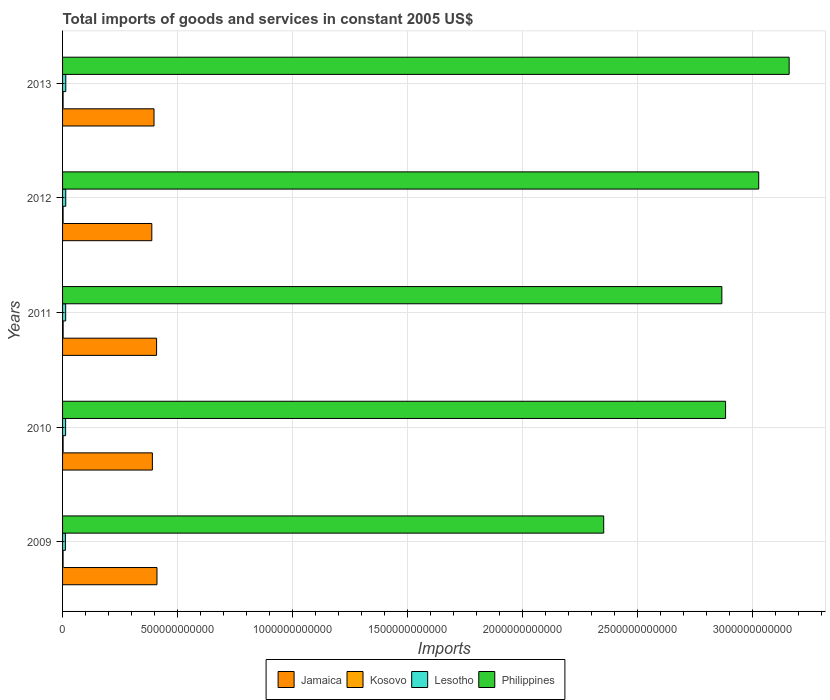How many bars are there on the 3rd tick from the bottom?
Make the answer very short. 4. In how many cases, is the number of bars for a given year not equal to the number of legend labels?
Ensure brevity in your answer.  0. What is the total imports of goods and services in Kosovo in 2012?
Your answer should be very brief. 2.33e+09. Across all years, what is the maximum total imports of goods and services in Lesotho?
Make the answer very short. 1.41e+1. Across all years, what is the minimum total imports of goods and services in Jamaica?
Provide a short and direct response. 3.88e+11. In which year was the total imports of goods and services in Lesotho maximum?
Your answer should be very brief. 2013. In which year was the total imports of goods and services in Jamaica minimum?
Give a very brief answer. 2012. What is the total total imports of goods and services in Jamaica in the graph?
Make the answer very short. 2.00e+12. What is the difference between the total imports of goods and services in Kosovo in 2012 and that in 2013?
Offer a terse response. 3.50e+07. What is the difference between the total imports of goods and services in Kosovo in 2009 and the total imports of goods and services in Jamaica in 2012?
Give a very brief answer. -3.86e+11. What is the average total imports of goods and services in Philippines per year?
Ensure brevity in your answer.  2.86e+12. In the year 2009, what is the difference between the total imports of goods and services in Jamaica and total imports of goods and services in Lesotho?
Ensure brevity in your answer.  3.98e+11. In how many years, is the total imports of goods and services in Lesotho greater than 3200000000000 US$?
Ensure brevity in your answer.  0. What is the ratio of the total imports of goods and services in Jamaica in 2010 to that in 2012?
Keep it short and to the point. 1.01. Is the total imports of goods and services in Kosovo in 2009 less than that in 2012?
Make the answer very short. Yes. Is the difference between the total imports of goods and services in Jamaica in 2011 and 2013 greater than the difference between the total imports of goods and services in Lesotho in 2011 and 2013?
Offer a terse response. Yes. What is the difference between the highest and the second highest total imports of goods and services in Kosovo?
Provide a succinct answer. 9.00e+07. What is the difference between the highest and the lowest total imports of goods and services in Kosovo?
Your answer should be very brief. 2.95e+08. In how many years, is the total imports of goods and services in Kosovo greater than the average total imports of goods and services in Kosovo taken over all years?
Offer a terse response. 2. Is it the case that in every year, the sum of the total imports of goods and services in Kosovo and total imports of goods and services in Lesotho is greater than the sum of total imports of goods and services in Philippines and total imports of goods and services in Jamaica?
Provide a succinct answer. No. What does the 2nd bar from the top in 2013 represents?
Provide a succinct answer. Lesotho. What does the 1st bar from the bottom in 2009 represents?
Offer a terse response. Jamaica. Are all the bars in the graph horizontal?
Your answer should be very brief. Yes. What is the difference between two consecutive major ticks on the X-axis?
Your answer should be compact. 5.00e+11. Are the values on the major ticks of X-axis written in scientific E-notation?
Ensure brevity in your answer.  No. Does the graph contain grids?
Provide a succinct answer. Yes. Where does the legend appear in the graph?
Your response must be concise. Bottom center. What is the title of the graph?
Your answer should be very brief. Total imports of goods and services in constant 2005 US$. What is the label or title of the X-axis?
Keep it short and to the point. Imports. What is the label or title of the Y-axis?
Your answer should be compact. Years. What is the Imports in Jamaica in 2009?
Give a very brief answer. 4.11e+11. What is the Imports of Kosovo in 2009?
Your answer should be compact. 2.23e+09. What is the Imports in Lesotho in 2009?
Provide a succinct answer. 1.23e+1. What is the Imports of Philippines in 2009?
Your answer should be compact. 2.35e+12. What is the Imports in Jamaica in 2010?
Provide a short and direct response. 3.91e+11. What is the Imports of Kosovo in 2010?
Make the answer very short. 2.44e+09. What is the Imports of Lesotho in 2010?
Ensure brevity in your answer.  1.32e+1. What is the Imports in Philippines in 2010?
Ensure brevity in your answer.  2.88e+12. What is the Imports of Jamaica in 2011?
Give a very brief answer. 4.09e+11. What is the Imports of Kosovo in 2011?
Keep it short and to the point. 2.53e+09. What is the Imports of Lesotho in 2011?
Your answer should be compact. 1.35e+1. What is the Imports in Philippines in 2011?
Ensure brevity in your answer.  2.87e+12. What is the Imports in Jamaica in 2012?
Provide a succinct answer. 3.88e+11. What is the Imports of Kosovo in 2012?
Offer a very short reply. 2.33e+09. What is the Imports of Lesotho in 2012?
Your answer should be compact. 1.39e+1. What is the Imports in Philippines in 2012?
Keep it short and to the point. 3.03e+12. What is the Imports of Jamaica in 2013?
Provide a short and direct response. 3.98e+11. What is the Imports in Kosovo in 2013?
Provide a succinct answer. 2.30e+09. What is the Imports in Lesotho in 2013?
Your answer should be very brief. 1.41e+1. What is the Imports in Philippines in 2013?
Offer a very short reply. 3.16e+12. Across all years, what is the maximum Imports of Jamaica?
Ensure brevity in your answer.  4.11e+11. Across all years, what is the maximum Imports in Kosovo?
Give a very brief answer. 2.53e+09. Across all years, what is the maximum Imports of Lesotho?
Offer a very short reply. 1.41e+1. Across all years, what is the maximum Imports of Philippines?
Your answer should be very brief. 3.16e+12. Across all years, what is the minimum Imports in Jamaica?
Provide a short and direct response. 3.88e+11. Across all years, what is the minimum Imports of Kosovo?
Keep it short and to the point. 2.23e+09. Across all years, what is the minimum Imports in Lesotho?
Your response must be concise. 1.23e+1. Across all years, what is the minimum Imports in Philippines?
Make the answer very short. 2.35e+12. What is the total Imports of Jamaica in the graph?
Provide a short and direct response. 2.00e+12. What is the total Imports in Kosovo in the graph?
Keep it short and to the point. 1.18e+1. What is the total Imports of Lesotho in the graph?
Give a very brief answer. 6.69e+1. What is the total Imports in Philippines in the graph?
Offer a very short reply. 1.43e+13. What is the difference between the Imports of Jamaica in 2009 and that in 2010?
Keep it short and to the point. 2.01e+1. What is the difference between the Imports in Kosovo in 2009 and that in 2010?
Provide a short and direct response. -2.05e+08. What is the difference between the Imports in Lesotho in 2009 and that in 2010?
Offer a very short reply. -9.55e+08. What is the difference between the Imports in Philippines in 2009 and that in 2010?
Make the answer very short. -5.30e+11. What is the difference between the Imports of Jamaica in 2009 and that in 2011?
Offer a terse response. 1.80e+09. What is the difference between the Imports in Kosovo in 2009 and that in 2011?
Offer a very short reply. -2.95e+08. What is the difference between the Imports of Lesotho in 2009 and that in 2011?
Make the answer very short. -1.24e+09. What is the difference between the Imports in Philippines in 2009 and that in 2011?
Ensure brevity in your answer.  -5.14e+11. What is the difference between the Imports in Jamaica in 2009 and that in 2012?
Offer a terse response. 2.25e+1. What is the difference between the Imports of Kosovo in 2009 and that in 2012?
Your response must be concise. -1.03e+08. What is the difference between the Imports in Lesotho in 2009 and that in 2012?
Offer a terse response. -1.59e+09. What is the difference between the Imports of Philippines in 2009 and that in 2012?
Ensure brevity in your answer.  -6.74e+11. What is the difference between the Imports in Jamaica in 2009 and that in 2013?
Make the answer very short. 1.29e+1. What is the difference between the Imports in Kosovo in 2009 and that in 2013?
Your answer should be compact. -6.79e+07. What is the difference between the Imports in Lesotho in 2009 and that in 2013?
Provide a succinct answer. -1.78e+09. What is the difference between the Imports of Philippines in 2009 and that in 2013?
Give a very brief answer. -8.07e+11. What is the difference between the Imports in Jamaica in 2010 and that in 2011?
Your answer should be compact. -1.83e+1. What is the difference between the Imports in Kosovo in 2010 and that in 2011?
Provide a succinct answer. -9.00e+07. What is the difference between the Imports in Lesotho in 2010 and that in 2011?
Keep it short and to the point. -2.89e+08. What is the difference between the Imports of Philippines in 2010 and that in 2011?
Your answer should be compact. 1.61e+1. What is the difference between the Imports of Jamaica in 2010 and that in 2012?
Your answer should be compact. 2.44e+09. What is the difference between the Imports in Kosovo in 2010 and that in 2012?
Keep it short and to the point. 1.02e+08. What is the difference between the Imports of Lesotho in 2010 and that in 2012?
Ensure brevity in your answer.  -6.33e+08. What is the difference between the Imports in Philippines in 2010 and that in 2012?
Provide a succinct answer. -1.44e+11. What is the difference between the Imports of Jamaica in 2010 and that in 2013?
Make the answer very short. -7.20e+09. What is the difference between the Imports in Kosovo in 2010 and that in 2013?
Ensure brevity in your answer.  1.37e+08. What is the difference between the Imports in Lesotho in 2010 and that in 2013?
Make the answer very short. -8.22e+08. What is the difference between the Imports in Philippines in 2010 and that in 2013?
Your response must be concise. -2.77e+11. What is the difference between the Imports of Jamaica in 2011 and that in 2012?
Keep it short and to the point. 2.07e+1. What is the difference between the Imports of Kosovo in 2011 and that in 2012?
Offer a very short reply. 1.92e+08. What is the difference between the Imports in Lesotho in 2011 and that in 2012?
Your response must be concise. -3.44e+08. What is the difference between the Imports in Philippines in 2011 and that in 2012?
Your response must be concise. -1.60e+11. What is the difference between the Imports in Jamaica in 2011 and that in 2013?
Provide a succinct answer. 1.11e+1. What is the difference between the Imports in Kosovo in 2011 and that in 2013?
Give a very brief answer. 2.27e+08. What is the difference between the Imports in Lesotho in 2011 and that in 2013?
Offer a terse response. -5.34e+08. What is the difference between the Imports in Philippines in 2011 and that in 2013?
Keep it short and to the point. -2.93e+11. What is the difference between the Imports in Jamaica in 2012 and that in 2013?
Give a very brief answer. -9.64e+09. What is the difference between the Imports in Kosovo in 2012 and that in 2013?
Offer a terse response. 3.50e+07. What is the difference between the Imports of Lesotho in 2012 and that in 2013?
Give a very brief answer. -1.89e+08. What is the difference between the Imports in Philippines in 2012 and that in 2013?
Provide a short and direct response. -1.32e+11. What is the difference between the Imports of Jamaica in 2009 and the Imports of Kosovo in 2010?
Ensure brevity in your answer.  4.08e+11. What is the difference between the Imports in Jamaica in 2009 and the Imports in Lesotho in 2010?
Your response must be concise. 3.98e+11. What is the difference between the Imports in Jamaica in 2009 and the Imports in Philippines in 2010?
Provide a succinct answer. -2.47e+12. What is the difference between the Imports in Kosovo in 2009 and the Imports in Lesotho in 2010?
Provide a succinct answer. -1.10e+1. What is the difference between the Imports in Kosovo in 2009 and the Imports in Philippines in 2010?
Provide a succinct answer. -2.88e+12. What is the difference between the Imports in Lesotho in 2009 and the Imports in Philippines in 2010?
Make the answer very short. -2.87e+12. What is the difference between the Imports of Jamaica in 2009 and the Imports of Kosovo in 2011?
Keep it short and to the point. 4.08e+11. What is the difference between the Imports of Jamaica in 2009 and the Imports of Lesotho in 2011?
Make the answer very short. 3.97e+11. What is the difference between the Imports in Jamaica in 2009 and the Imports in Philippines in 2011?
Your answer should be very brief. -2.46e+12. What is the difference between the Imports in Kosovo in 2009 and the Imports in Lesotho in 2011?
Offer a very short reply. -1.13e+1. What is the difference between the Imports in Kosovo in 2009 and the Imports in Philippines in 2011?
Offer a terse response. -2.87e+12. What is the difference between the Imports of Lesotho in 2009 and the Imports of Philippines in 2011?
Provide a succinct answer. -2.86e+12. What is the difference between the Imports in Jamaica in 2009 and the Imports in Kosovo in 2012?
Make the answer very short. 4.08e+11. What is the difference between the Imports in Jamaica in 2009 and the Imports in Lesotho in 2012?
Your answer should be very brief. 3.97e+11. What is the difference between the Imports in Jamaica in 2009 and the Imports in Philippines in 2012?
Give a very brief answer. -2.62e+12. What is the difference between the Imports in Kosovo in 2009 and the Imports in Lesotho in 2012?
Ensure brevity in your answer.  -1.16e+1. What is the difference between the Imports in Kosovo in 2009 and the Imports in Philippines in 2012?
Ensure brevity in your answer.  -3.03e+12. What is the difference between the Imports in Lesotho in 2009 and the Imports in Philippines in 2012?
Make the answer very short. -3.02e+12. What is the difference between the Imports in Jamaica in 2009 and the Imports in Kosovo in 2013?
Keep it short and to the point. 4.08e+11. What is the difference between the Imports of Jamaica in 2009 and the Imports of Lesotho in 2013?
Offer a terse response. 3.97e+11. What is the difference between the Imports in Jamaica in 2009 and the Imports in Philippines in 2013?
Keep it short and to the point. -2.75e+12. What is the difference between the Imports in Kosovo in 2009 and the Imports in Lesotho in 2013?
Your response must be concise. -1.18e+1. What is the difference between the Imports in Kosovo in 2009 and the Imports in Philippines in 2013?
Keep it short and to the point. -3.16e+12. What is the difference between the Imports of Lesotho in 2009 and the Imports of Philippines in 2013?
Give a very brief answer. -3.15e+12. What is the difference between the Imports in Jamaica in 2010 and the Imports in Kosovo in 2011?
Ensure brevity in your answer.  3.88e+11. What is the difference between the Imports of Jamaica in 2010 and the Imports of Lesotho in 2011?
Ensure brevity in your answer.  3.77e+11. What is the difference between the Imports of Jamaica in 2010 and the Imports of Philippines in 2011?
Provide a succinct answer. -2.48e+12. What is the difference between the Imports in Kosovo in 2010 and the Imports in Lesotho in 2011?
Your answer should be very brief. -1.11e+1. What is the difference between the Imports of Kosovo in 2010 and the Imports of Philippines in 2011?
Provide a succinct answer. -2.87e+12. What is the difference between the Imports in Lesotho in 2010 and the Imports in Philippines in 2011?
Offer a very short reply. -2.85e+12. What is the difference between the Imports of Jamaica in 2010 and the Imports of Kosovo in 2012?
Keep it short and to the point. 3.88e+11. What is the difference between the Imports in Jamaica in 2010 and the Imports in Lesotho in 2012?
Your response must be concise. 3.77e+11. What is the difference between the Imports in Jamaica in 2010 and the Imports in Philippines in 2012?
Provide a short and direct response. -2.64e+12. What is the difference between the Imports in Kosovo in 2010 and the Imports in Lesotho in 2012?
Give a very brief answer. -1.14e+1. What is the difference between the Imports in Kosovo in 2010 and the Imports in Philippines in 2012?
Make the answer very short. -3.03e+12. What is the difference between the Imports of Lesotho in 2010 and the Imports of Philippines in 2012?
Make the answer very short. -3.02e+12. What is the difference between the Imports in Jamaica in 2010 and the Imports in Kosovo in 2013?
Offer a terse response. 3.88e+11. What is the difference between the Imports in Jamaica in 2010 and the Imports in Lesotho in 2013?
Ensure brevity in your answer.  3.77e+11. What is the difference between the Imports of Jamaica in 2010 and the Imports of Philippines in 2013?
Offer a very short reply. -2.77e+12. What is the difference between the Imports in Kosovo in 2010 and the Imports in Lesotho in 2013?
Your response must be concise. -1.16e+1. What is the difference between the Imports in Kosovo in 2010 and the Imports in Philippines in 2013?
Your answer should be compact. -3.16e+12. What is the difference between the Imports of Lesotho in 2010 and the Imports of Philippines in 2013?
Give a very brief answer. -3.15e+12. What is the difference between the Imports in Jamaica in 2011 and the Imports in Kosovo in 2012?
Your answer should be very brief. 4.07e+11. What is the difference between the Imports in Jamaica in 2011 and the Imports in Lesotho in 2012?
Give a very brief answer. 3.95e+11. What is the difference between the Imports in Jamaica in 2011 and the Imports in Philippines in 2012?
Make the answer very short. -2.62e+12. What is the difference between the Imports in Kosovo in 2011 and the Imports in Lesotho in 2012?
Your answer should be very brief. -1.13e+1. What is the difference between the Imports of Kosovo in 2011 and the Imports of Philippines in 2012?
Keep it short and to the point. -3.03e+12. What is the difference between the Imports of Lesotho in 2011 and the Imports of Philippines in 2012?
Give a very brief answer. -3.01e+12. What is the difference between the Imports of Jamaica in 2011 and the Imports of Kosovo in 2013?
Provide a short and direct response. 4.07e+11. What is the difference between the Imports of Jamaica in 2011 and the Imports of Lesotho in 2013?
Ensure brevity in your answer.  3.95e+11. What is the difference between the Imports in Jamaica in 2011 and the Imports in Philippines in 2013?
Ensure brevity in your answer.  -2.75e+12. What is the difference between the Imports in Kosovo in 2011 and the Imports in Lesotho in 2013?
Your answer should be compact. -1.15e+1. What is the difference between the Imports of Kosovo in 2011 and the Imports of Philippines in 2013?
Make the answer very short. -3.16e+12. What is the difference between the Imports in Lesotho in 2011 and the Imports in Philippines in 2013?
Provide a succinct answer. -3.15e+12. What is the difference between the Imports of Jamaica in 2012 and the Imports of Kosovo in 2013?
Keep it short and to the point. 3.86e+11. What is the difference between the Imports in Jamaica in 2012 and the Imports in Lesotho in 2013?
Your response must be concise. 3.74e+11. What is the difference between the Imports of Jamaica in 2012 and the Imports of Philippines in 2013?
Offer a very short reply. -2.77e+12. What is the difference between the Imports of Kosovo in 2012 and the Imports of Lesotho in 2013?
Provide a succinct answer. -1.17e+1. What is the difference between the Imports in Kosovo in 2012 and the Imports in Philippines in 2013?
Your answer should be compact. -3.16e+12. What is the difference between the Imports in Lesotho in 2012 and the Imports in Philippines in 2013?
Your answer should be very brief. -3.15e+12. What is the average Imports in Jamaica per year?
Your answer should be compact. 3.99e+11. What is the average Imports of Kosovo per year?
Your response must be concise. 2.36e+09. What is the average Imports of Lesotho per year?
Provide a succinct answer. 1.34e+1. What is the average Imports of Philippines per year?
Your response must be concise. 2.86e+12. In the year 2009, what is the difference between the Imports of Jamaica and Imports of Kosovo?
Offer a terse response. 4.09e+11. In the year 2009, what is the difference between the Imports of Jamaica and Imports of Lesotho?
Your answer should be very brief. 3.98e+11. In the year 2009, what is the difference between the Imports in Jamaica and Imports in Philippines?
Your answer should be compact. -1.94e+12. In the year 2009, what is the difference between the Imports in Kosovo and Imports in Lesotho?
Offer a terse response. -1.00e+1. In the year 2009, what is the difference between the Imports of Kosovo and Imports of Philippines?
Offer a very short reply. -2.35e+12. In the year 2009, what is the difference between the Imports of Lesotho and Imports of Philippines?
Provide a succinct answer. -2.34e+12. In the year 2010, what is the difference between the Imports of Jamaica and Imports of Kosovo?
Provide a short and direct response. 3.88e+11. In the year 2010, what is the difference between the Imports in Jamaica and Imports in Lesotho?
Give a very brief answer. 3.77e+11. In the year 2010, what is the difference between the Imports of Jamaica and Imports of Philippines?
Offer a terse response. -2.49e+12. In the year 2010, what is the difference between the Imports of Kosovo and Imports of Lesotho?
Keep it short and to the point. -1.08e+1. In the year 2010, what is the difference between the Imports of Kosovo and Imports of Philippines?
Keep it short and to the point. -2.88e+12. In the year 2010, what is the difference between the Imports in Lesotho and Imports in Philippines?
Ensure brevity in your answer.  -2.87e+12. In the year 2011, what is the difference between the Imports of Jamaica and Imports of Kosovo?
Give a very brief answer. 4.06e+11. In the year 2011, what is the difference between the Imports in Jamaica and Imports in Lesotho?
Offer a terse response. 3.95e+11. In the year 2011, what is the difference between the Imports of Jamaica and Imports of Philippines?
Your answer should be compact. -2.46e+12. In the year 2011, what is the difference between the Imports of Kosovo and Imports of Lesotho?
Your answer should be compact. -1.10e+1. In the year 2011, what is the difference between the Imports of Kosovo and Imports of Philippines?
Make the answer very short. -2.87e+12. In the year 2011, what is the difference between the Imports in Lesotho and Imports in Philippines?
Your answer should be very brief. -2.85e+12. In the year 2012, what is the difference between the Imports of Jamaica and Imports of Kosovo?
Keep it short and to the point. 3.86e+11. In the year 2012, what is the difference between the Imports in Jamaica and Imports in Lesotho?
Provide a short and direct response. 3.74e+11. In the year 2012, what is the difference between the Imports in Jamaica and Imports in Philippines?
Make the answer very short. -2.64e+12. In the year 2012, what is the difference between the Imports in Kosovo and Imports in Lesotho?
Ensure brevity in your answer.  -1.15e+1. In the year 2012, what is the difference between the Imports in Kosovo and Imports in Philippines?
Your answer should be compact. -3.03e+12. In the year 2012, what is the difference between the Imports of Lesotho and Imports of Philippines?
Give a very brief answer. -3.01e+12. In the year 2013, what is the difference between the Imports in Jamaica and Imports in Kosovo?
Offer a terse response. 3.96e+11. In the year 2013, what is the difference between the Imports of Jamaica and Imports of Lesotho?
Your answer should be compact. 3.84e+11. In the year 2013, what is the difference between the Imports of Jamaica and Imports of Philippines?
Provide a succinct answer. -2.76e+12. In the year 2013, what is the difference between the Imports in Kosovo and Imports in Lesotho?
Ensure brevity in your answer.  -1.18e+1. In the year 2013, what is the difference between the Imports of Kosovo and Imports of Philippines?
Ensure brevity in your answer.  -3.16e+12. In the year 2013, what is the difference between the Imports in Lesotho and Imports in Philippines?
Keep it short and to the point. -3.15e+12. What is the ratio of the Imports of Jamaica in 2009 to that in 2010?
Your answer should be very brief. 1.05. What is the ratio of the Imports in Kosovo in 2009 to that in 2010?
Provide a short and direct response. 0.92. What is the ratio of the Imports in Lesotho in 2009 to that in 2010?
Provide a succinct answer. 0.93. What is the ratio of the Imports in Philippines in 2009 to that in 2010?
Offer a terse response. 0.82. What is the ratio of the Imports of Kosovo in 2009 to that in 2011?
Your answer should be compact. 0.88. What is the ratio of the Imports in Lesotho in 2009 to that in 2011?
Keep it short and to the point. 0.91. What is the ratio of the Imports of Philippines in 2009 to that in 2011?
Give a very brief answer. 0.82. What is the ratio of the Imports in Jamaica in 2009 to that in 2012?
Your answer should be compact. 1.06. What is the ratio of the Imports of Kosovo in 2009 to that in 2012?
Offer a very short reply. 0.96. What is the ratio of the Imports in Lesotho in 2009 to that in 2012?
Provide a short and direct response. 0.89. What is the ratio of the Imports of Philippines in 2009 to that in 2012?
Offer a terse response. 0.78. What is the ratio of the Imports of Jamaica in 2009 to that in 2013?
Your answer should be very brief. 1.03. What is the ratio of the Imports in Kosovo in 2009 to that in 2013?
Your answer should be very brief. 0.97. What is the ratio of the Imports in Lesotho in 2009 to that in 2013?
Offer a very short reply. 0.87. What is the ratio of the Imports of Philippines in 2009 to that in 2013?
Ensure brevity in your answer.  0.74. What is the ratio of the Imports of Jamaica in 2010 to that in 2011?
Offer a terse response. 0.96. What is the ratio of the Imports in Kosovo in 2010 to that in 2011?
Keep it short and to the point. 0.96. What is the ratio of the Imports of Lesotho in 2010 to that in 2011?
Provide a short and direct response. 0.98. What is the ratio of the Imports of Philippines in 2010 to that in 2011?
Ensure brevity in your answer.  1.01. What is the ratio of the Imports in Jamaica in 2010 to that in 2012?
Keep it short and to the point. 1.01. What is the ratio of the Imports in Kosovo in 2010 to that in 2012?
Offer a very short reply. 1.04. What is the ratio of the Imports of Lesotho in 2010 to that in 2012?
Your response must be concise. 0.95. What is the ratio of the Imports of Jamaica in 2010 to that in 2013?
Offer a very short reply. 0.98. What is the ratio of the Imports in Kosovo in 2010 to that in 2013?
Offer a very short reply. 1.06. What is the ratio of the Imports in Lesotho in 2010 to that in 2013?
Offer a very short reply. 0.94. What is the ratio of the Imports in Philippines in 2010 to that in 2013?
Your answer should be very brief. 0.91. What is the ratio of the Imports of Jamaica in 2011 to that in 2012?
Offer a very short reply. 1.05. What is the ratio of the Imports in Kosovo in 2011 to that in 2012?
Provide a short and direct response. 1.08. What is the ratio of the Imports in Lesotho in 2011 to that in 2012?
Provide a succinct answer. 0.98. What is the ratio of the Imports of Philippines in 2011 to that in 2012?
Your answer should be compact. 0.95. What is the ratio of the Imports in Jamaica in 2011 to that in 2013?
Your answer should be compact. 1.03. What is the ratio of the Imports of Kosovo in 2011 to that in 2013?
Provide a short and direct response. 1.1. What is the ratio of the Imports of Philippines in 2011 to that in 2013?
Your response must be concise. 0.91. What is the ratio of the Imports in Jamaica in 2012 to that in 2013?
Offer a terse response. 0.98. What is the ratio of the Imports of Kosovo in 2012 to that in 2013?
Give a very brief answer. 1.02. What is the ratio of the Imports in Lesotho in 2012 to that in 2013?
Keep it short and to the point. 0.99. What is the ratio of the Imports in Philippines in 2012 to that in 2013?
Make the answer very short. 0.96. What is the difference between the highest and the second highest Imports of Jamaica?
Offer a very short reply. 1.80e+09. What is the difference between the highest and the second highest Imports of Kosovo?
Offer a terse response. 9.00e+07. What is the difference between the highest and the second highest Imports in Lesotho?
Provide a short and direct response. 1.89e+08. What is the difference between the highest and the second highest Imports of Philippines?
Your answer should be compact. 1.32e+11. What is the difference between the highest and the lowest Imports in Jamaica?
Provide a short and direct response. 2.25e+1. What is the difference between the highest and the lowest Imports in Kosovo?
Make the answer very short. 2.95e+08. What is the difference between the highest and the lowest Imports in Lesotho?
Provide a succinct answer. 1.78e+09. What is the difference between the highest and the lowest Imports in Philippines?
Ensure brevity in your answer.  8.07e+11. 